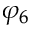Convert formula to latex. <formula><loc_0><loc_0><loc_500><loc_500>\varphi _ { 6 }</formula> 